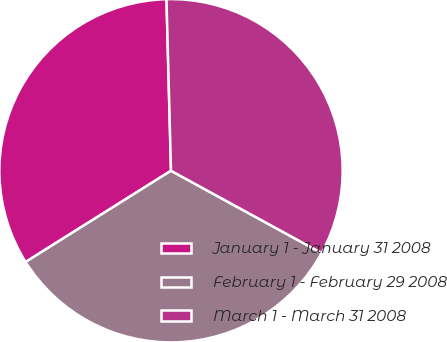Convert chart to OTSL. <chart><loc_0><loc_0><loc_500><loc_500><pie_chart><fcel>January 1 - January 31 2008<fcel>February 1 - February 29 2008<fcel>March 1 - March 31 2008<nl><fcel>33.5%<fcel>33.12%<fcel>33.38%<nl></chart> 